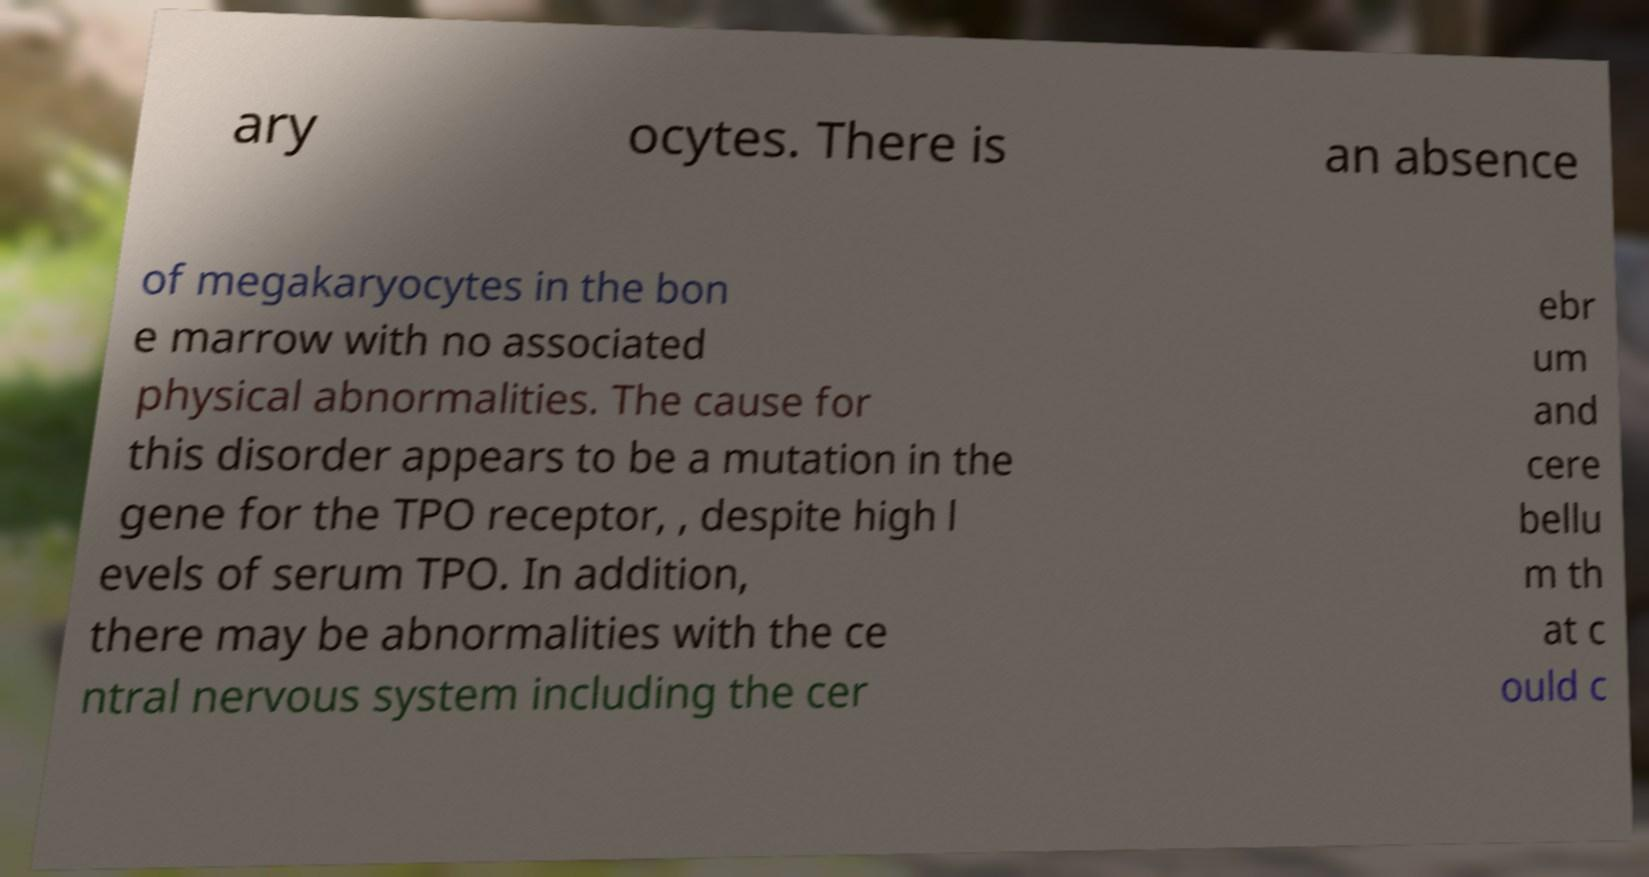Please read and relay the text visible in this image. What does it say? ary ocytes. There is an absence of megakaryocytes in the bon e marrow with no associated physical abnormalities. The cause for this disorder appears to be a mutation in the gene for the TPO receptor, , despite high l evels of serum TPO. In addition, there may be abnormalities with the ce ntral nervous system including the cer ebr um and cere bellu m th at c ould c 